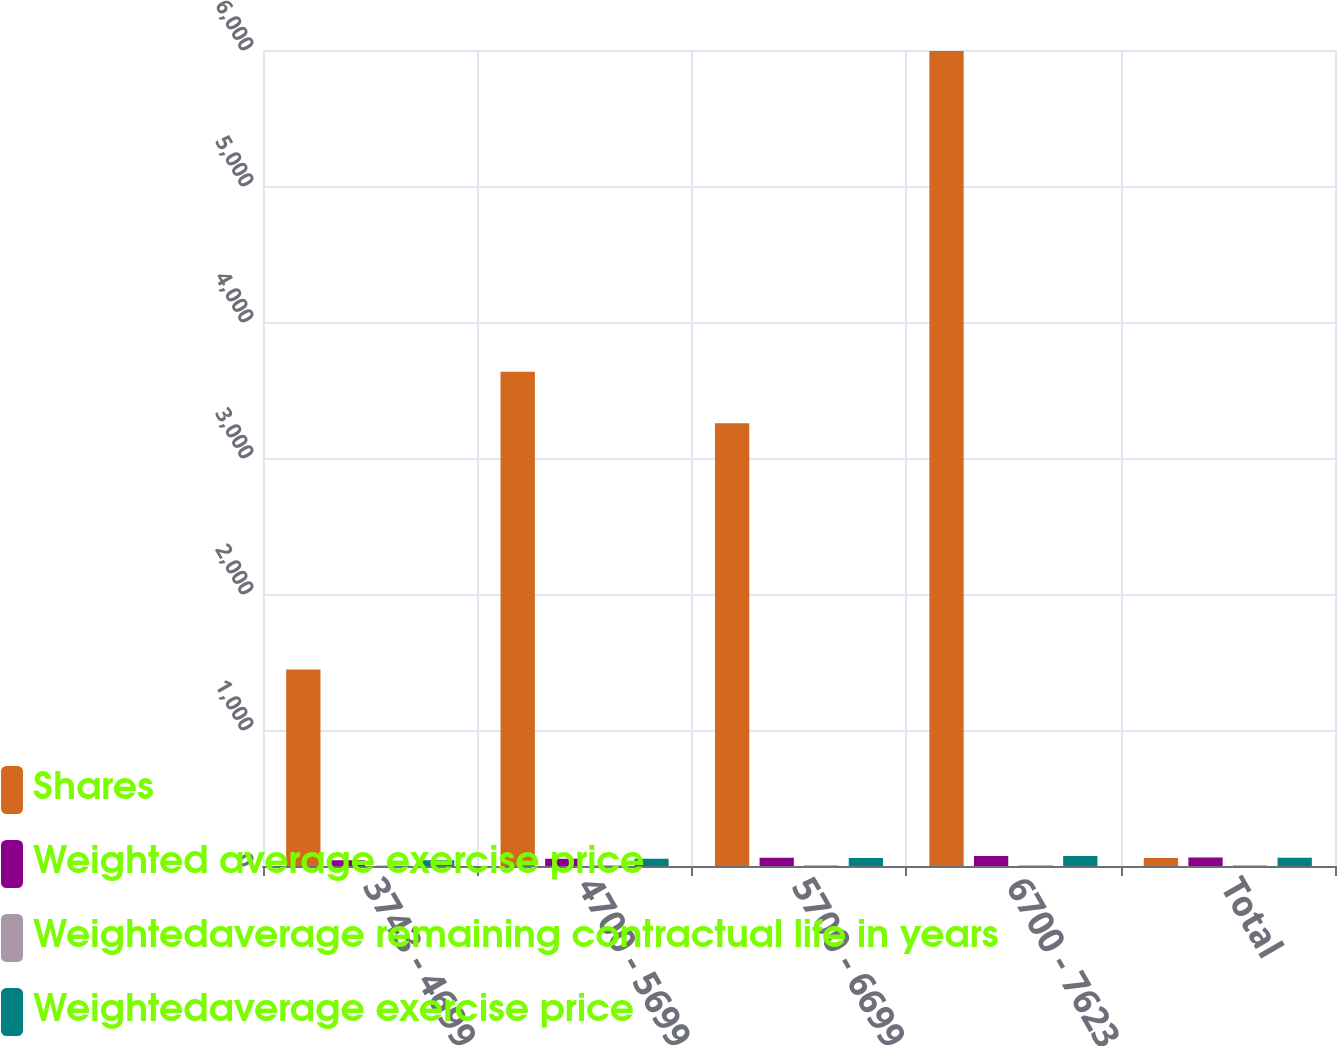Convert chart. <chart><loc_0><loc_0><loc_500><loc_500><stacked_bar_chart><ecel><fcel>3743 - 4699<fcel>4700 - 5699<fcel>5700 - 6699<fcel>6700 - 7623<fcel>Total<nl><fcel>Shares<fcel>1444<fcel>3634<fcel>3255<fcel>5993<fcel>58.96<nl><fcel>Weighted average exercise price<fcel>43.05<fcel>53.43<fcel>60.32<fcel>73.03<fcel>62.15<nl><fcel>Weightedaverage remaining contractual life in years<fcel>4<fcel>5.4<fcel>5.2<fcel>5.5<fcel>5.3<nl><fcel>Weightedaverage exercise price<fcel>43.05<fcel>53.4<fcel>58.96<fcel>73.45<fcel>59.95<nl></chart> 